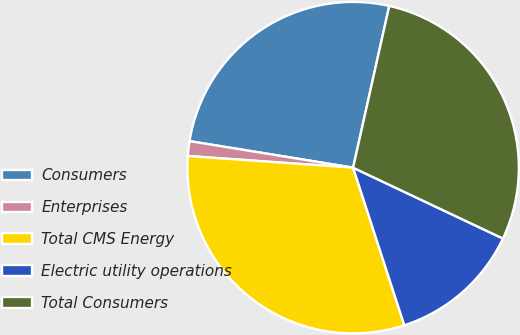<chart> <loc_0><loc_0><loc_500><loc_500><pie_chart><fcel>Consumers<fcel>Enterprises<fcel>Total CMS Energy<fcel>Electric utility operations<fcel>Total Consumers<nl><fcel>25.94%<fcel>1.44%<fcel>31.12%<fcel>12.97%<fcel>28.53%<nl></chart> 